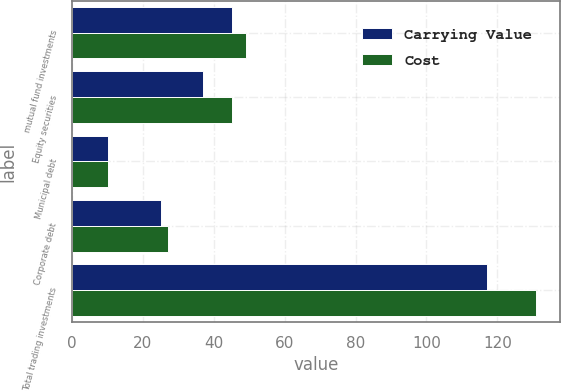Convert chart. <chart><loc_0><loc_0><loc_500><loc_500><stacked_bar_chart><ecel><fcel>mutual fund investments<fcel>Equity securities<fcel>Municipal debt<fcel>Corporate debt<fcel>Total trading investments<nl><fcel>Carrying Value<fcel>45<fcel>37<fcel>10<fcel>25<fcel>117<nl><fcel>Cost<fcel>49<fcel>45<fcel>10<fcel>27<fcel>131<nl></chart> 